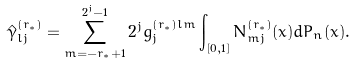Convert formula to latex. <formula><loc_0><loc_0><loc_500><loc_500>\hat { \gamma } _ { l j } ^ { ( r _ { \ast } ) } = \sum _ { m = - r _ { \ast } + 1 } ^ { 2 ^ { j } - 1 } 2 ^ { j } g _ { j } ^ { ( r _ { \ast } ) l m } \int _ { [ 0 , 1 ] } N _ { m j } ^ { ( r _ { \ast } ) } ( x ) d P _ { n } ( x ) .</formula> 